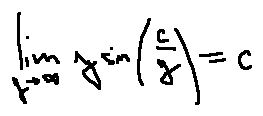<formula> <loc_0><loc_0><loc_500><loc_500>\lim \lim i t s _ { y \rightarrow \infty } y \sin ( \frac { c } { y } ) = c</formula> 